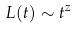<formula> <loc_0><loc_0><loc_500><loc_500>L ( t ) \sim t ^ { z }</formula> 